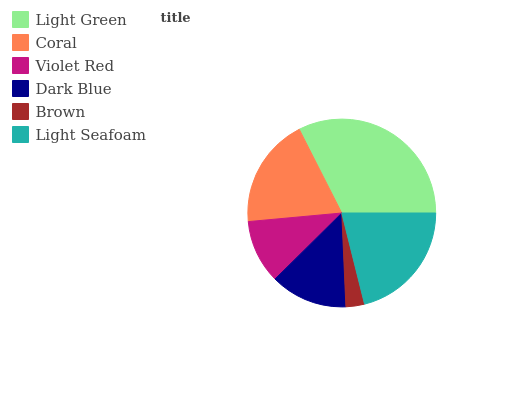Is Brown the minimum?
Answer yes or no. Yes. Is Light Green the maximum?
Answer yes or no. Yes. Is Coral the minimum?
Answer yes or no. No. Is Coral the maximum?
Answer yes or no. No. Is Light Green greater than Coral?
Answer yes or no. Yes. Is Coral less than Light Green?
Answer yes or no. Yes. Is Coral greater than Light Green?
Answer yes or no. No. Is Light Green less than Coral?
Answer yes or no. No. Is Coral the high median?
Answer yes or no. Yes. Is Dark Blue the low median?
Answer yes or no. Yes. Is Light Seafoam the high median?
Answer yes or no. No. Is Coral the low median?
Answer yes or no. No. 